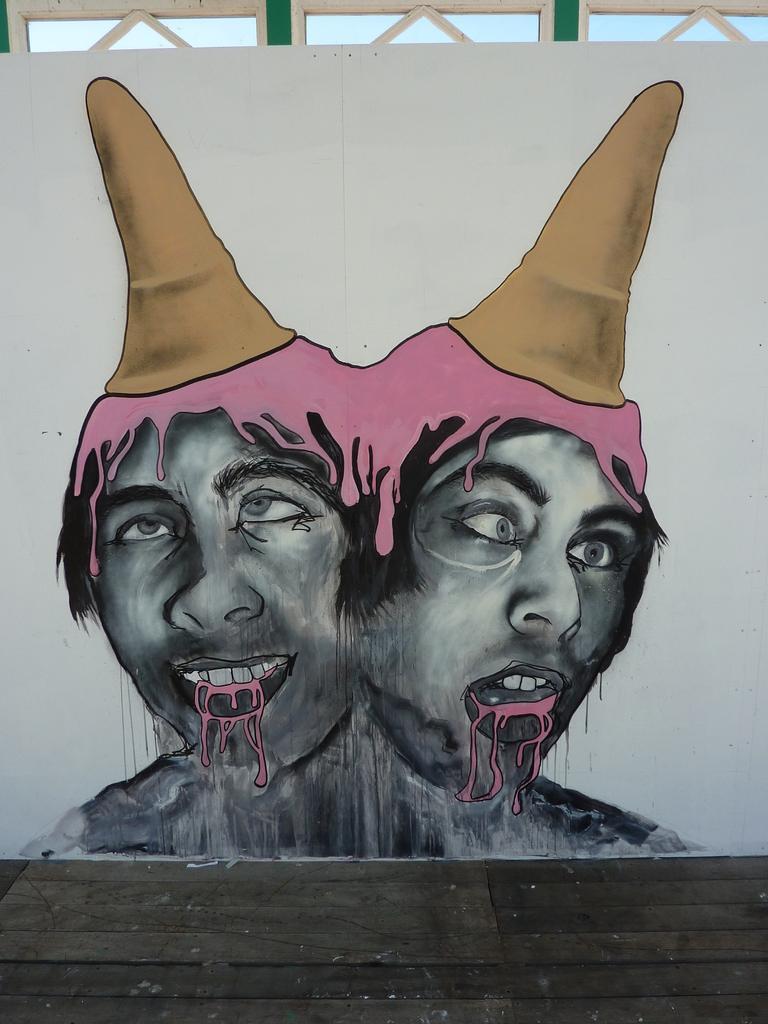Describe this image in one or two sentences. In this picture we can see the person's paintings on the wall. At the bottom we can see the wooden floor. At the top we can see the sky. 